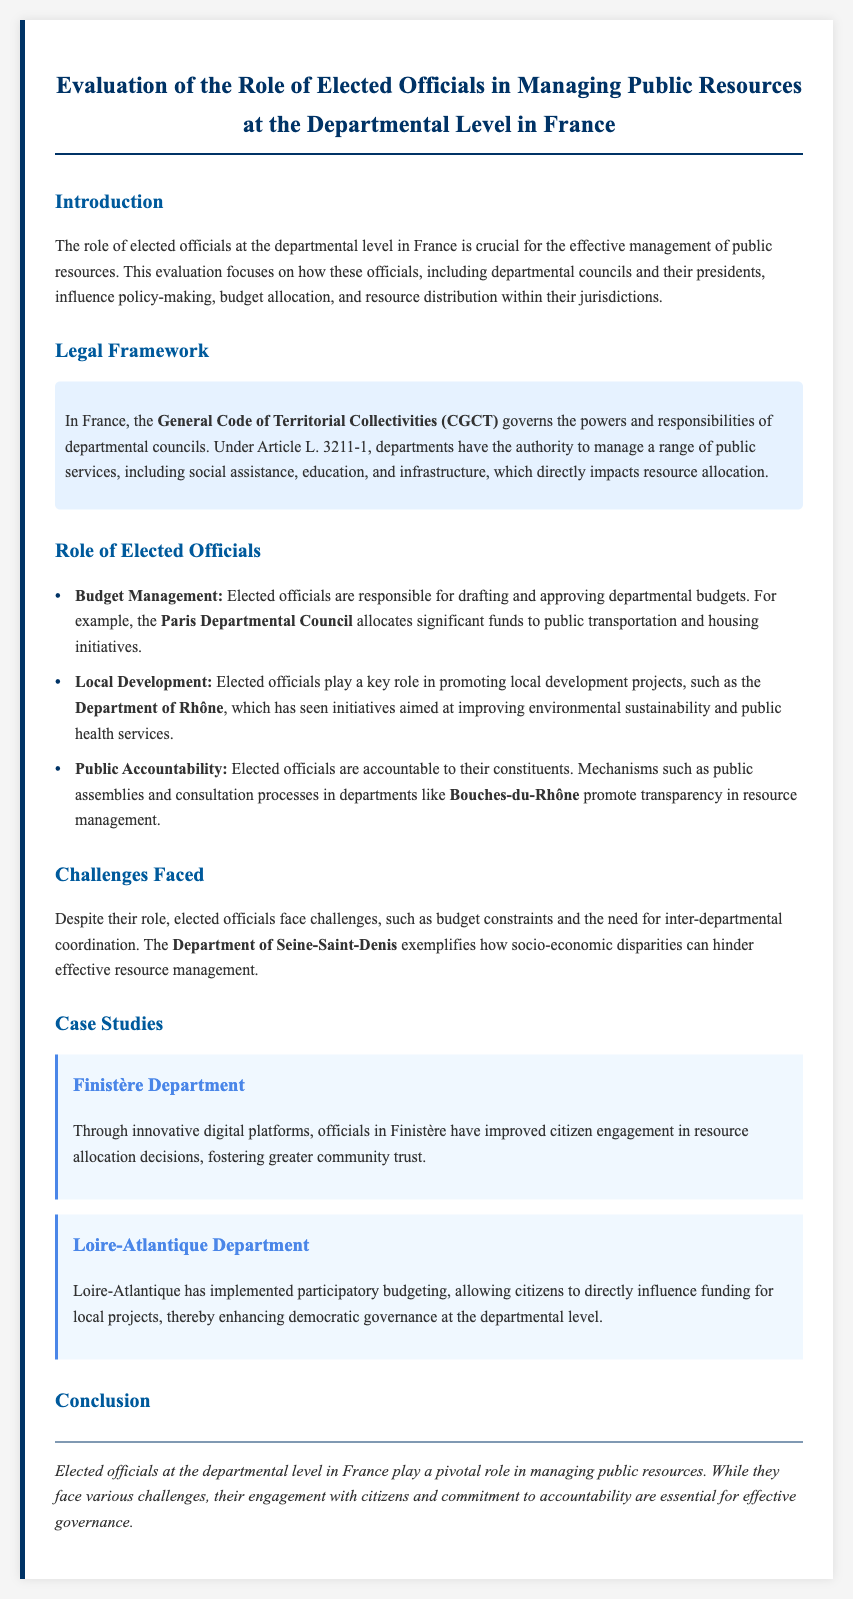What governs the powers of departmental councils in France? The document states that the powers and responsibilities of departmental councils are governed by the General Code of Territorial Collectivities (CGCT).
Answer: General Code of Territorial Collectivities (CGCT) What is one responsibility of elected officials mentioned in the document? The document lists several responsibilities, including drafting and approving departmental budgets.
Answer: Budget Management Which department allocates significant funds to public transportation? The document specifically mentions the Paris Departmental Council regarding significant fund allocation to public transportation.
Answer: Paris Departmental Council What innovative approach was used in the Finistère Department? The document states that officials in Finistère have improved citizen engagement through innovative digital platforms.
Answer: Digital platforms What challenge is highlighted in the Department of Seine-Saint-Denis? The document mentions socio-economic disparities as a challenge in the Department of Seine-Saint-Denis.
Answer: Socio-economic disparities What participatory method is implemented in Loire-Atlantique? The document mentions that Loire-Atlantique has implemented participatory budgeting.
Answer: Participatory budgeting What is a key theme of the conclusion? The conclusion emphasizes the engagement of elected officials with citizens as essential for effective governance.
Answer: Engagement with citizens How does the document categorize its content? The content is categorized under sections like Introduction, Legal Framework, Role of Elected Officials, Challenges Faced, Case Studies, and Conclusion.
Answer: Sections 